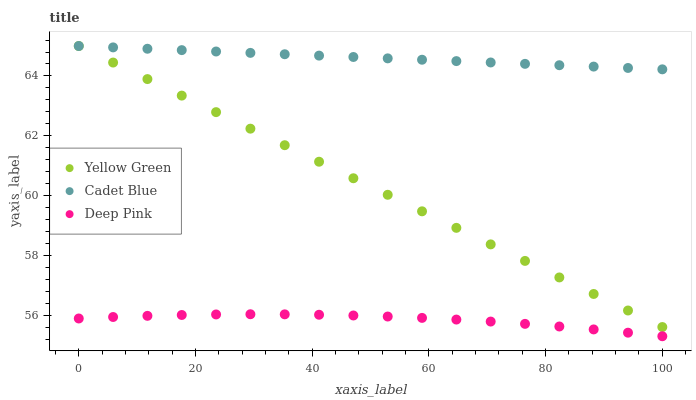Does Deep Pink have the minimum area under the curve?
Answer yes or no. Yes. Does Cadet Blue have the maximum area under the curve?
Answer yes or no. Yes. Does Yellow Green have the minimum area under the curve?
Answer yes or no. No. Does Yellow Green have the maximum area under the curve?
Answer yes or no. No. Is Yellow Green the smoothest?
Answer yes or no. Yes. Is Deep Pink the roughest?
Answer yes or no. Yes. Is Deep Pink the smoothest?
Answer yes or no. No. Is Yellow Green the roughest?
Answer yes or no. No. Does Deep Pink have the lowest value?
Answer yes or no. Yes. Does Yellow Green have the lowest value?
Answer yes or no. No. Does Yellow Green have the highest value?
Answer yes or no. Yes. Does Deep Pink have the highest value?
Answer yes or no. No. Is Deep Pink less than Yellow Green?
Answer yes or no. Yes. Is Yellow Green greater than Deep Pink?
Answer yes or no. Yes. Does Cadet Blue intersect Yellow Green?
Answer yes or no. Yes. Is Cadet Blue less than Yellow Green?
Answer yes or no. No. Is Cadet Blue greater than Yellow Green?
Answer yes or no. No. Does Deep Pink intersect Yellow Green?
Answer yes or no. No. 